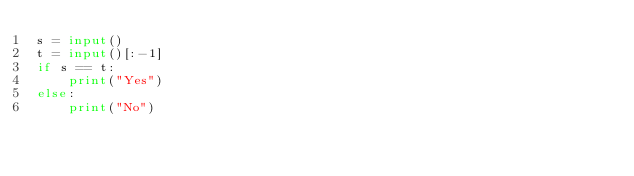<code> <loc_0><loc_0><loc_500><loc_500><_Python_>s = input()
t = input()[:-1]
if s == t:
    print("Yes")
else:
    print("No")</code> 